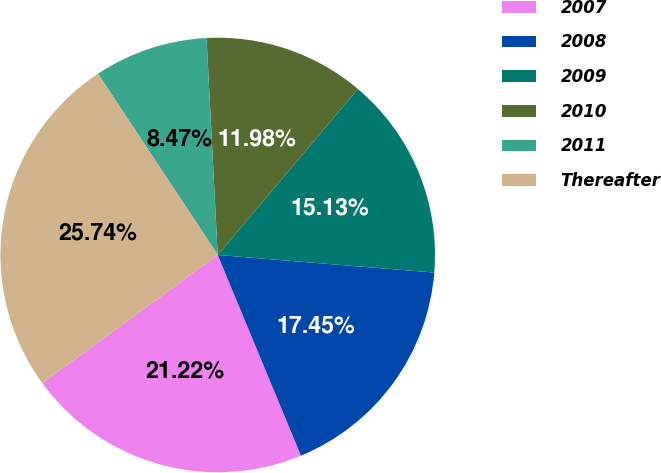Convert chart. <chart><loc_0><loc_0><loc_500><loc_500><pie_chart><fcel>2007<fcel>2008<fcel>2009<fcel>2010<fcel>2011<fcel>Thereafter<nl><fcel>21.22%<fcel>17.45%<fcel>15.13%<fcel>11.98%<fcel>8.47%<fcel>25.74%<nl></chart> 